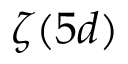Convert formula to latex. <formula><loc_0><loc_0><loc_500><loc_500>\zeta ( 5 d )</formula> 